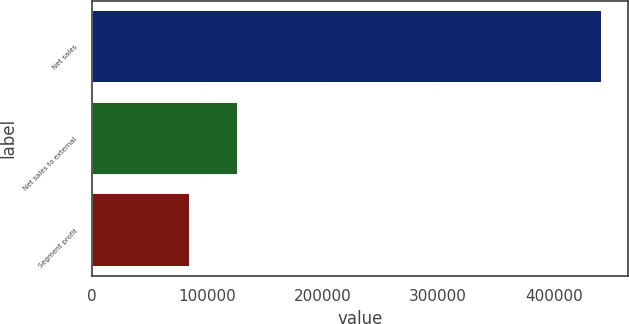<chart> <loc_0><loc_0><loc_500><loc_500><bar_chart><fcel>Net sales<fcel>Net sales to external<fcel>Segment profit<nl><fcel>442054<fcel>126476<fcel>85363<nl></chart> 